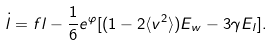<formula> <loc_0><loc_0><loc_500><loc_500>\dot { l } = f l - \frac { 1 } { 6 } e ^ { \varphi } [ ( 1 - 2 \langle v ^ { 2 } \rangle ) E _ { w } - 3 \gamma E _ { l } ] .</formula> 